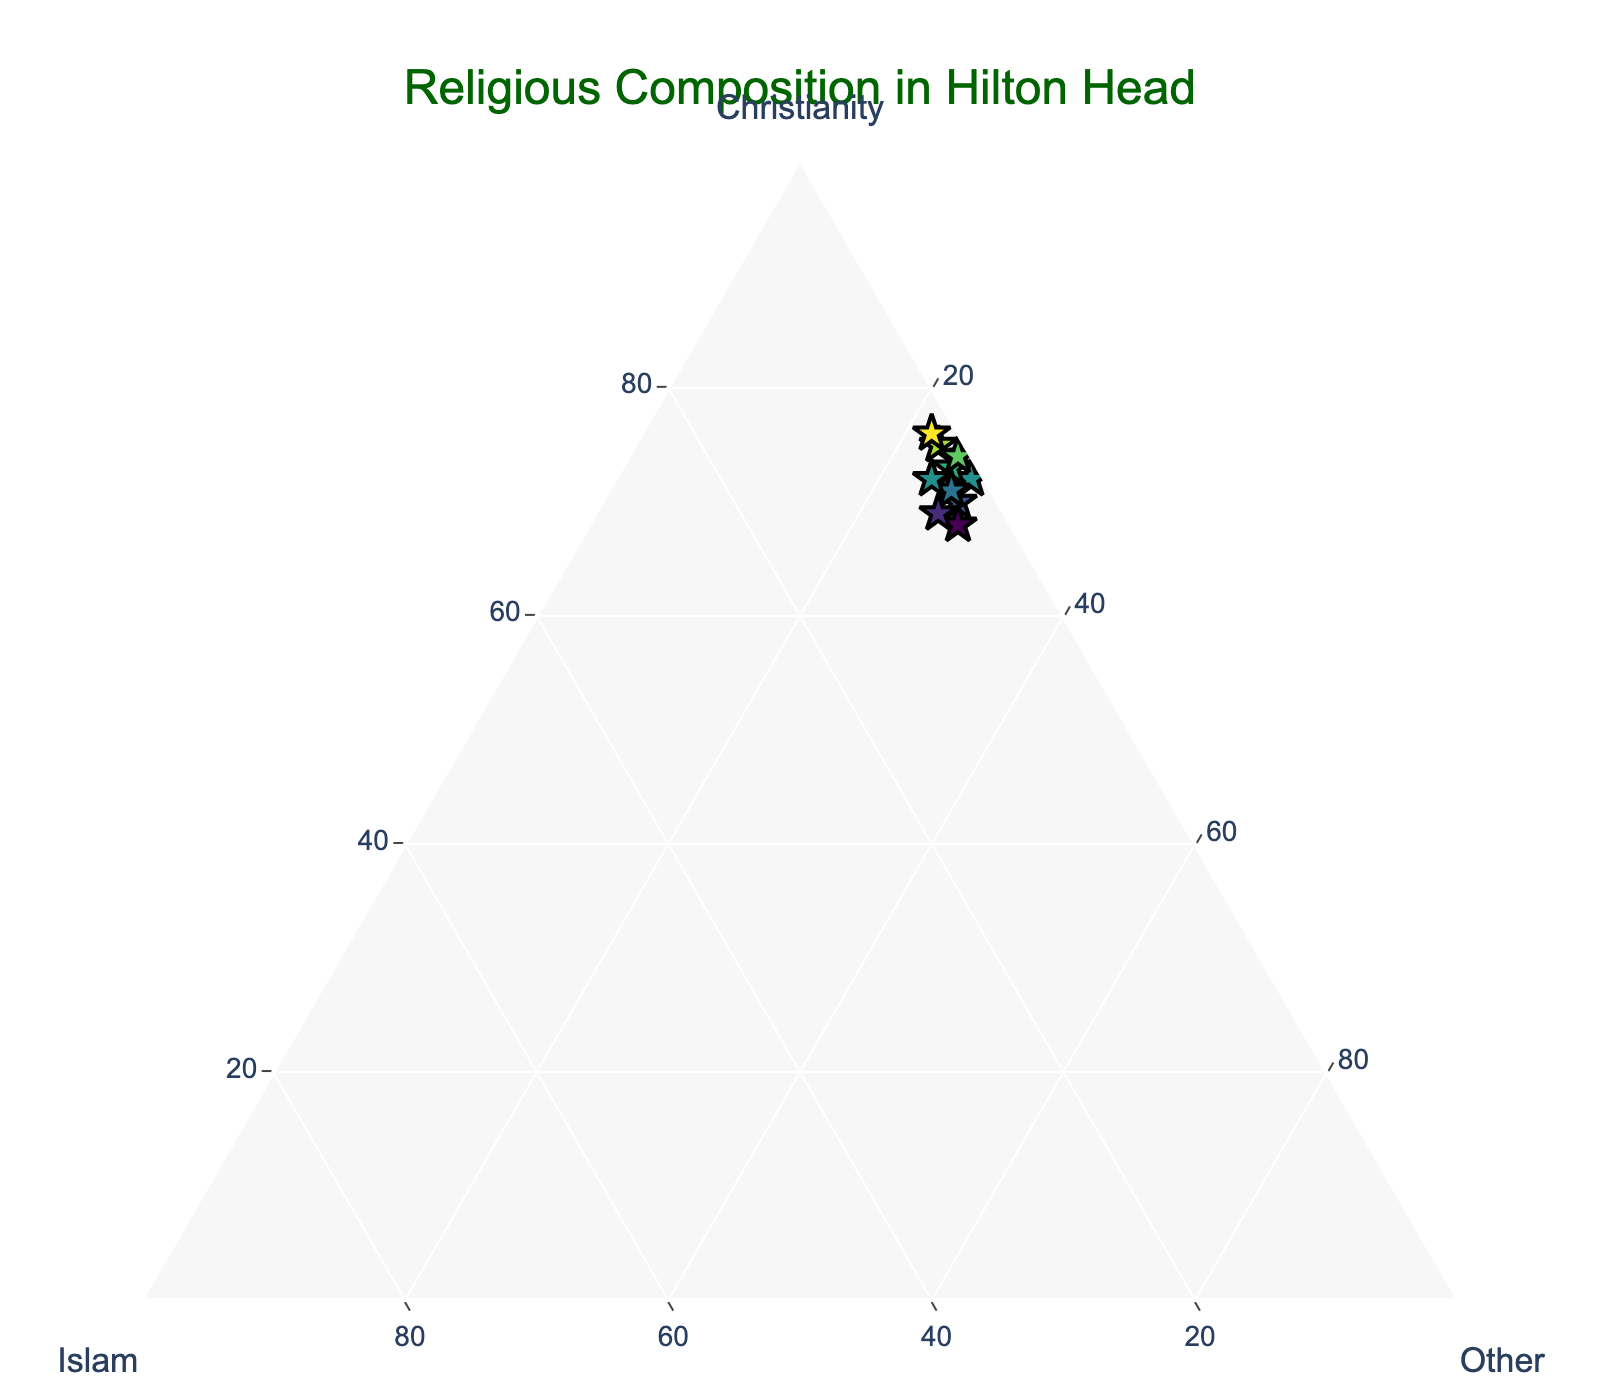what is the title of the plot? The title is usually placed at the top center of the plot. Here, it reads "Religious Composition in Hilton Head".
Answer: Religious Composition in Hilton Head how many data points are displayed in the plot? Each point is represented by a star marker in the plot, and counting them gives a total of 10 data points.
Answer: 10 what is the highest percentage of "Islam" observed in the data points? The highest value for Islam can be found among the scatter points; the maximum percentage shown here is 5.
Answer: 5 what are the color and size characteristics of the markers in the plot? The markers are star-shaped, sized at 14, and colored in a shades-of-green colorscale which indicate the Christianity percentage.
Answer: star-shaped, size 14, shades of green which axis represents the "Other" religious affiliation? In a ternary plot, each side of the triangle represents an axis. Here, the 'c' axis (one of the three axes) is labeled "Other".
Answer: 'c' axis what is the average percentage of 'Christianity' in the dataset? Adding all Christian percentages (75, 70, 72, 68, 73, 71, 69, 74, 76, 72) gives 720, and dividing by the number of data points (10) gives the average as 72%.
Answer: 72 using visual observation, which religious affiliation shows the least variation across the data points? Comparing the spreads of the three affiliations, Islam shows the least variation, with data points clustered close together between 1-5%.
Answer: Islam are there any data points that show an equal percentage of 'Islam' and 'Other'? By observing the hover text on each data point, no data points display equal percentages for Islam and Other; they all show different values.
Answer: No if a data point has 4% 'Islam' and 68% 'Christianity,' can you identify the percentage for 'Other' religious affiliations? For the ternary plot, the total sum for each point is 100%. Given Islam and Christianity are 4% and 68%, the percentage for Other is 100% - 4% - 68% = 28%.
Answer: 28 